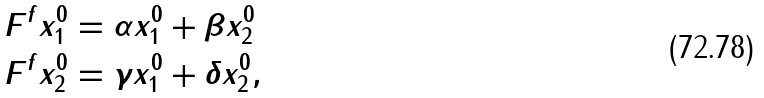Convert formula to latex. <formula><loc_0><loc_0><loc_500><loc_500>F ^ { f } x ^ { 0 } _ { 1 } & = \alpha x ^ { 0 } _ { 1 } + \beta x ^ { 0 } _ { 2 } \\ F ^ { f } x ^ { 0 } _ { 2 } & = \gamma x ^ { 0 } _ { 1 } + \delta x ^ { 0 } _ { 2 } , \\</formula> 